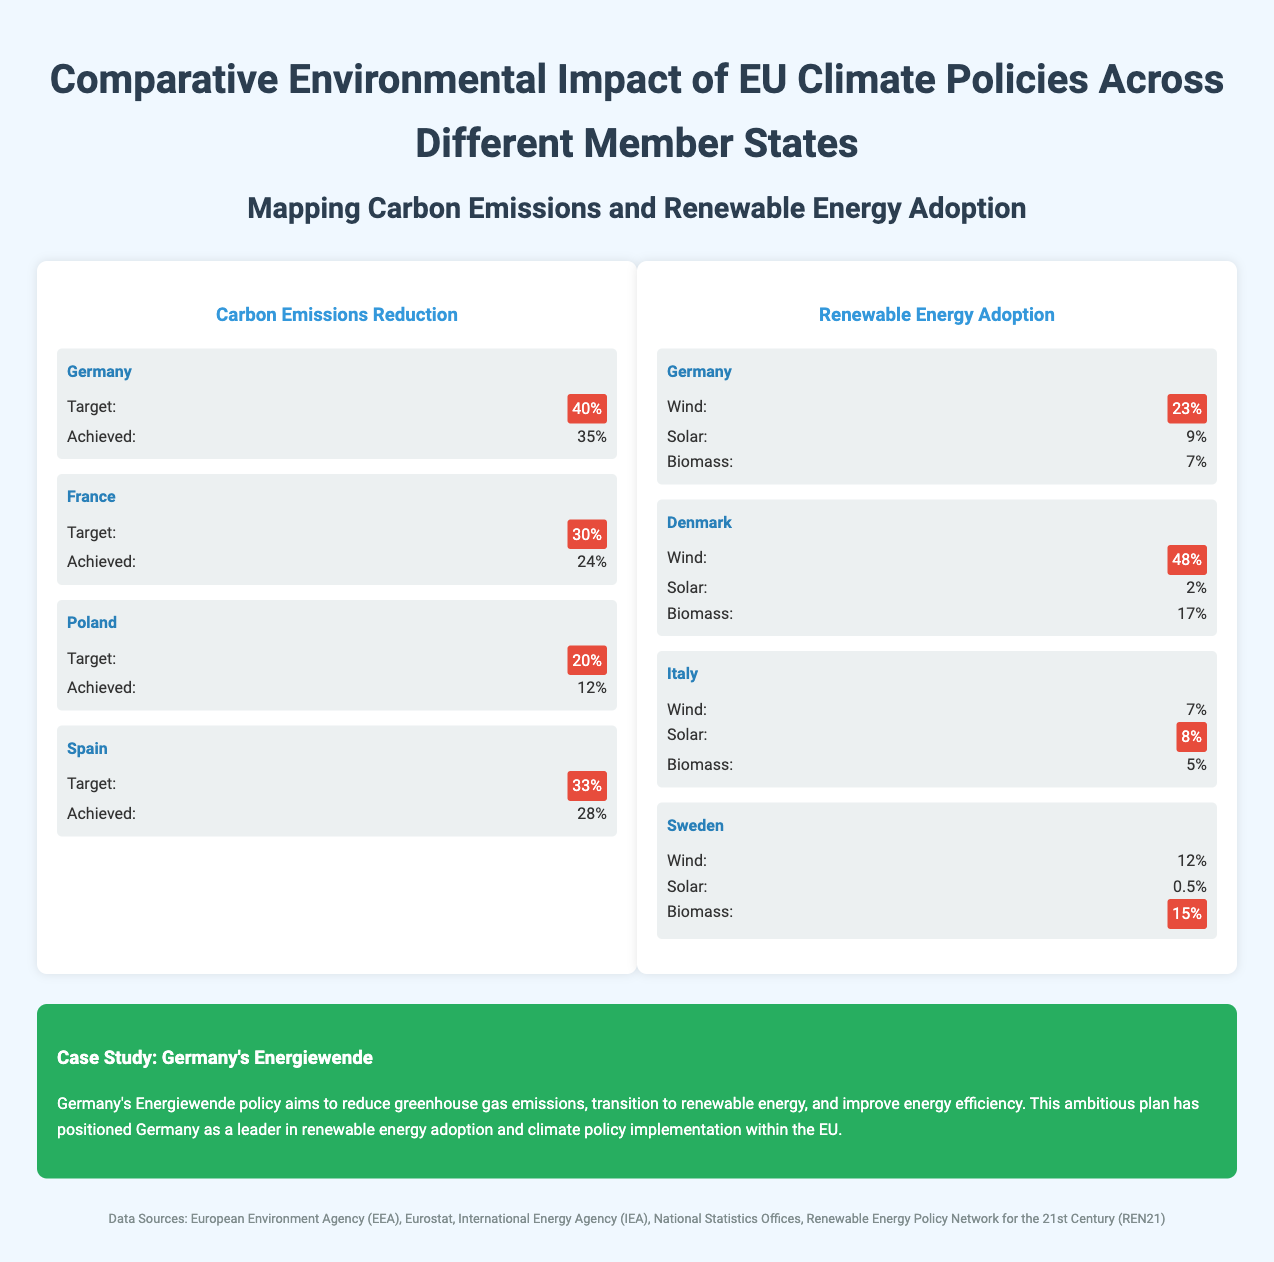What was Germany's target for carbon emissions reduction? Germany's target for carbon emissions reduction is stated in the document as 40%.
Answer: 40% What percentage of carbon emissions reduction has France achieved? The document provides the achieved carbon emissions reduction for France as 24%.
Answer: 24% Which country has the highest percentage of wind energy adoption? The infographic specifies that Denmark has the highest wind energy adoption at 48%.
Answer: 48% What is the achieved percentage of carbon emissions reduction for Poland? Poland's achieved carbon emissions reduction is noted in the document as 12%.
Answer: 12% What is the focus of Germany's Energiewende policy? The case study in the document indicates that Germany's Energiewende policy focuses on reducing greenhouse gas emissions.
Answer: Reducing greenhouse gas emissions Which renewable energy source contributes the most to Denmark's energy mix? The document highlights that wind energy contributes the most at 48% for Denmark.
Answer: Wind Which country has a higher target for carbon emissions reduction, Spain or Poland? The document indicates that Spain has a target of 33%, while Poland has 20%, thus Spain has a higher target.
Answer: Spain What percentage of renewable energy does Sweden generate from biomass? The document lists Sweden's renewable energy generation from biomass as 15%.
Answer: 15% Which organization is one of the data sources? The document mentions several sources, and the European Environment Agency (EEA) is one of them.
Answer: European Environment Agency (EEA) 